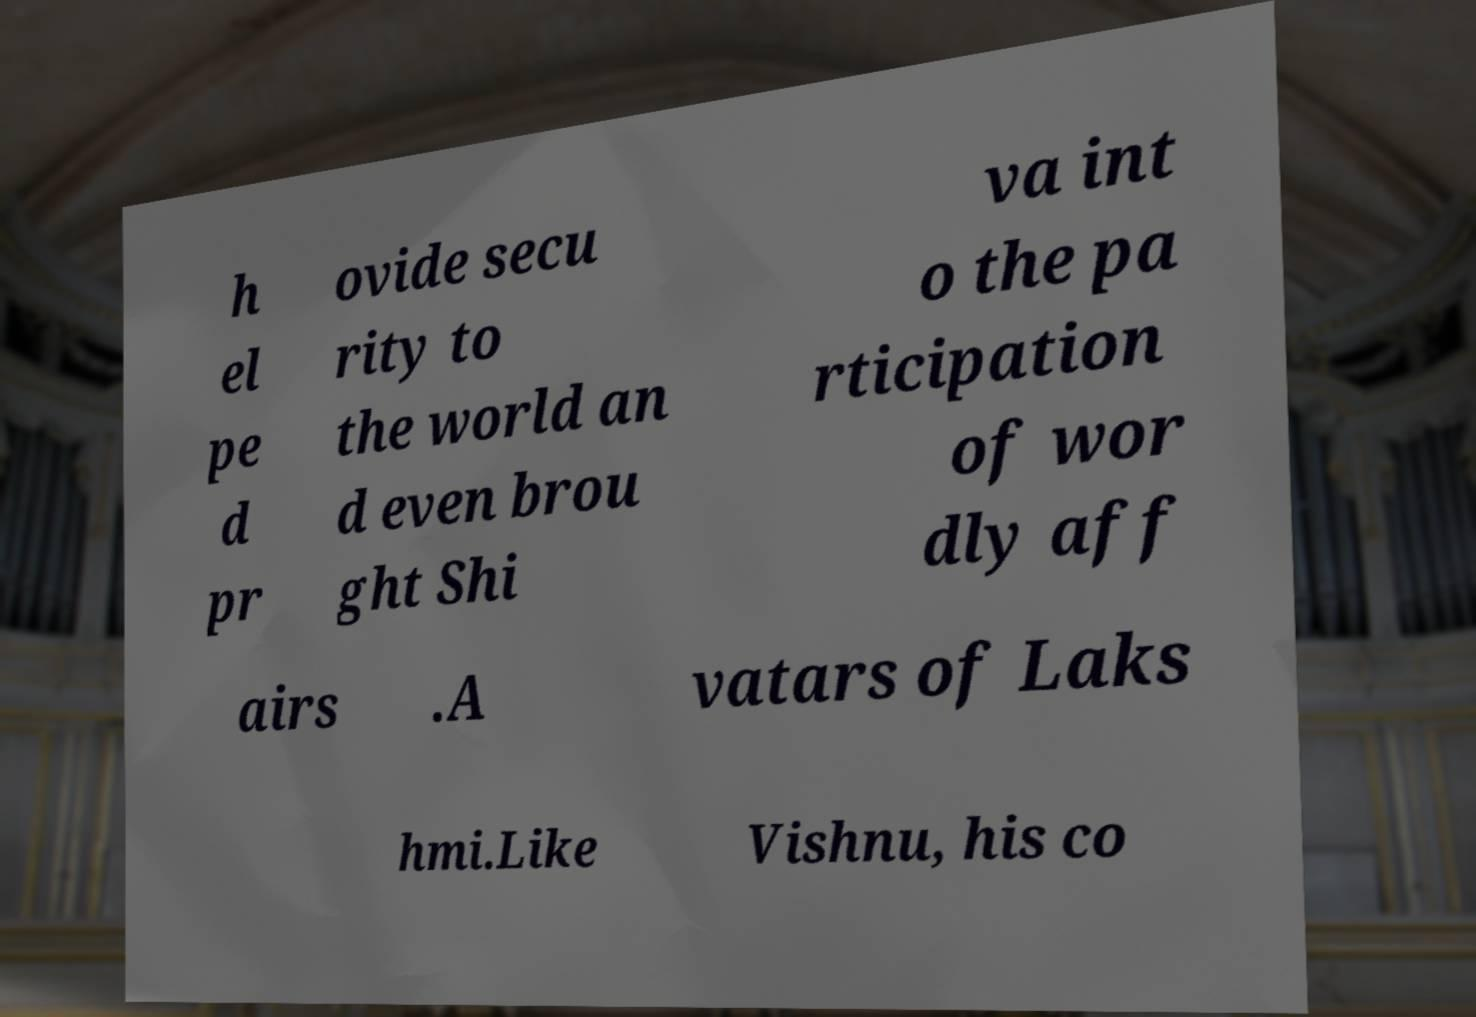What messages or text are displayed in this image? I need them in a readable, typed format. h el pe d pr ovide secu rity to the world an d even brou ght Shi va int o the pa rticipation of wor dly aff airs .A vatars of Laks hmi.Like Vishnu, his co 